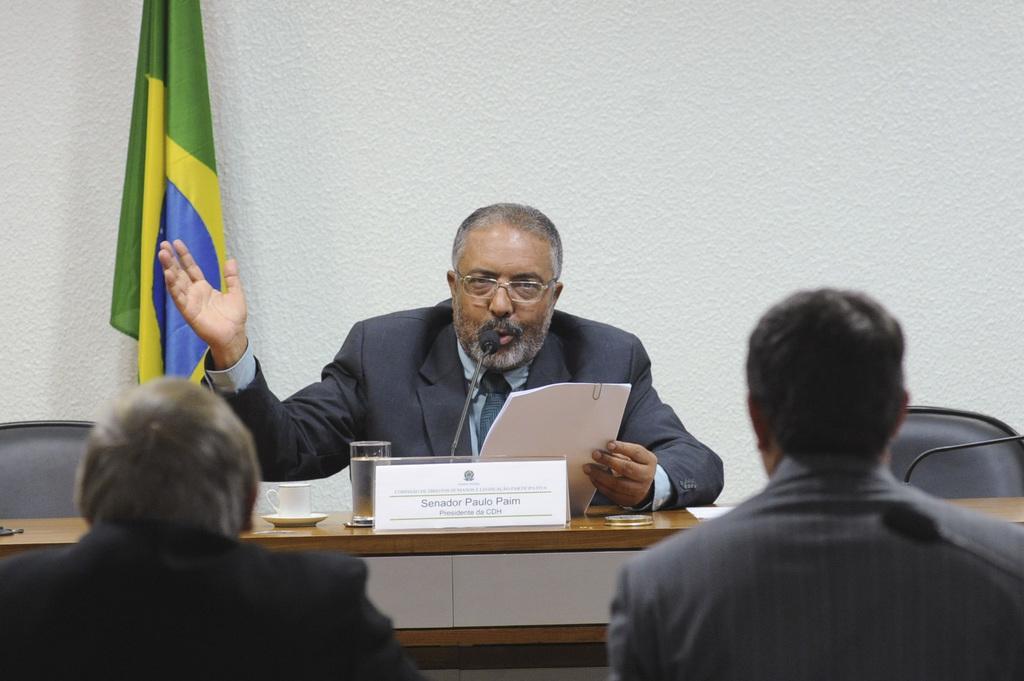Can you describe this image briefly? In the center of the image we can see a man sitting in front of the table and holding the papers and on the table we can see a cup, saucer, glass of water, name board and also a mike. We can also see two empty chairs and also two other persons. In the background there is a plain wall and also a flag. 